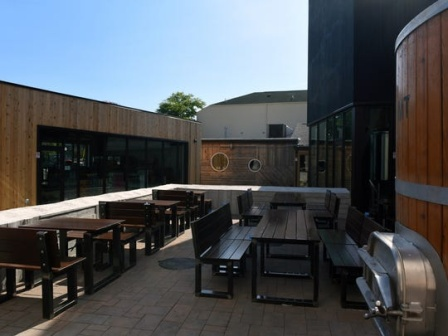Describe the atmosphere at the brewery patio during a busy weekend afternoon. During a busy weekend afternoon, the brewery patio would be alive with energy and camaraderie. The wooden tables and benches would be filled with groups of friends and family, enjoying hearty laughter and lively conversations. Glasses filled with various brews would sparkle in the sunlight, and the air would be filled with the rich aromas of freshly brewed beer and perhaps some tantalizing snacks from a nearby food truck. The fermenters on the side would stand as silent sentinels, a constant reminder of the craftsmanship that goes into each drink enjoyed by the patrons. What kind of events might this brewery patio host under the evening stars? Under the evening stars, the brewery patio transforms into an enchanting venue for a variety of events. It could host live acoustic music performances, where local artists strum guitars or play soothing melodies, creating a relaxed and intimate ambiance. The brewery might organize themed nights, perhaps featuring trivia or open mic sessions, encouraging both laughter and thoughtful engagement. During festive seasons, it could be adorned with fairy lights, hosting community gatherings or holiday celebrations where guests can enjoy limited edition brews and seasonal treats. The patio’s warm, wooden seating and the soft glow of the fermenters’ steel add to the cozy charm, making it a perfect spot for romantic dates, friends’ night out, or even casual business meetups. Can you imagine a fantastical event that could bring magic to this brewery patio? Absolutely! Imagine a 'Brewery Under the Stars' night where the patio is transformed into an enchanted forest. The wooden tables and benches are covered with lush vines and twinkling fairy lights. There are whimsical decorations like lanterns hanging from invisible threads and a small stage where a magician performs feats of illusion, leaving spectators in awe. Across the patio, small stalls offer enchanted brews with names like 'Elven Nectar' and 'Wizard's Ale,' each drink served in ornate goblets that emit a soft, magical glow. There are storytellers spinning tales of fantasy and wonder in cozy nooks, while a harpist plays ethereal music that floats gently through the air. The large fermenters are transformed into 'Mystic Cauldrons,' bubbling with gleaming, otherworldly liquids. It’s a night where reality blends seamlessly with fantasy, leaving everyone with a sense of wonder and enchantment. 